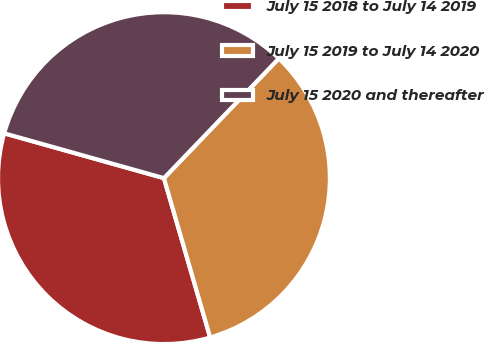Convert chart to OTSL. <chart><loc_0><loc_0><loc_500><loc_500><pie_chart><fcel>July 15 2018 to July 14 2019<fcel>July 15 2019 to July 14 2020<fcel>July 15 2020 and thereafter<nl><fcel>33.85%<fcel>33.33%<fcel>32.82%<nl></chart> 